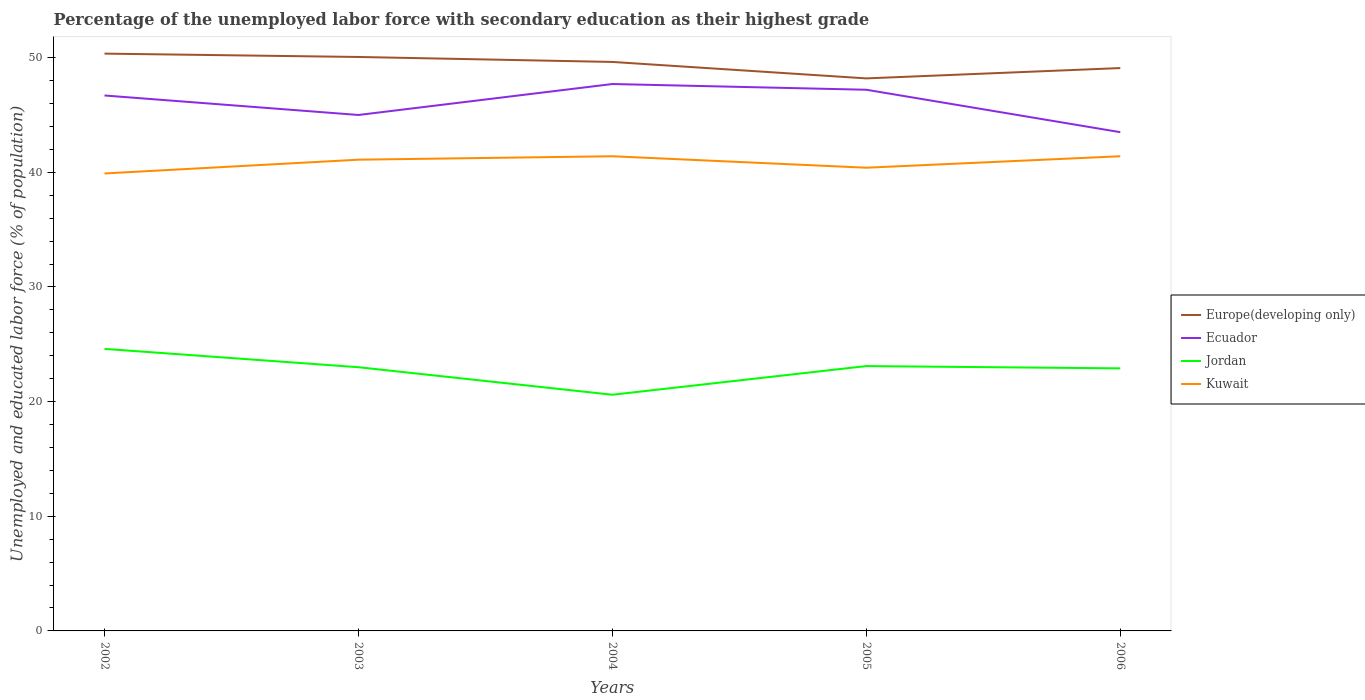How many different coloured lines are there?
Provide a succinct answer. 4. Is the number of lines equal to the number of legend labels?
Offer a very short reply. Yes. Across all years, what is the maximum percentage of the unemployed labor force with secondary education in Jordan?
Offer a terse response. 20.6. In which year was the percentage of the unemployed labor force with secondary education in Jordan maximum?
Your response must be concise. 2004. What is the total percentage of the unemployed labor force with secondary education in Jordan in the graph?
Offer a very short reply. -2.3. What is the difference between the highest and the second highest percentage of the unemployed labor force with secondary education in Europe(developing only)?
Provide a succinct answer. 2.16. Where does the legend appear in the graph?
Offer a terse response. Center right. What is the title of the graph?
Provide a short and direct response. Percentage of the unemployed labor force with secondary education as their highest grade. What is the label or title of the Y-axis?
Provide a short and direct response. Unemployed and educated labor force (% of population). What is the Unemployed and educated labor force (% of population) in Europe(developing only) in 2002?
Make the answer very short. 50.35. What is the Unemployed and educated labor force (% of population) of Ecuador in 2002?
Provide a succinct answer. 46.7. What is the Unemployed and educated labor force (% of population) of Jordan in 2002?
Your answer should be compact. 24.6. What is the Unemployed and educated labor force (% of population) in Kuwait in 2002?
Make the answer very short. 39.9. What is the Unemployed and educated labor force (% of population) of Europe(developing only) in 2003?
Keep it short and to the point. 50.06. What is the Unemployed and educated labor force (% of population) of Kuwait in 2003?
Keep it short and to the point. 41.1. What is the Unemployed and educated labor force (% of population) in Europe(developing only) in 2004?
Offer a very short reply. 49.63. What is the Unemployed and educated labor force (% of population) of Ecuador in 2004?
Your response must be concise. 47.7. What is the Unemployed and educated labor force (% of population) of Jordan in 2004?
Your answer should be very brief. 20.6. What is the Unemployed and educated labor force (% of population) of Kuwait in 2004?
Provide a short and direct response. 41.4. What is the Unemployed and educated labor force (% of population) in Europe(developing only) in 2005?
Provide a succinct answer. 48.19. What is the Unemployed and educated labor force (% of population) of Ecuador in 2005?
Give a very brief answer. 47.2. What is the Unemployed and educated labor force (% of population) of Jordan in 2005?
Provide a short and direct response. 23.1. What is the Unemployed and educated labor force (% of population) in Kuwait in 2005?
Make the answer very short. 40.4. What is the Unemployed and educated labor force (% of population) of Europe(developing only) in 2006?
Offer a terse response. 49.09. What is the Unemployed and educated labor force (% of population) of Ecuador in 2006?
Provide a short and direct response. 43.5. What is the Unemployed and educated labor force (% of population) of Jordan in 2006?
Provide a succinct answer. 22.9. What is the Unemployed and educated labor force (% of population) in Kuwait in 2006?
Offer a terse response. 41.4. Across all years, what is the maximum Unemployed and educated labor force (% of population) of Europe(developing only)?
Keep it short and to the point. 50.35. Across all years, what is the maximum Unemployed and educated labor force (% of population) of Ecuador?
Ensure brevity in your answer.  47.7. Across all years, what is the maximum Unemployed and educated labor force (% of population) in Jordan?
Offer a terse response. 24.6. Across all years, what is the maximum Unemployed and educated labor force (% of population) of Kuwait?
Your answer should be compact. 41.4. Across all years, what is the minimum Unemployed and educated labor force (% of population) of Europe(developing only)?
Give a very brief answer. 48.19. Across all years, what is the minimum Unemployed and educated labor force (% of population) in Ecuador?
Make the answer very short. 43.5. Across all years, what is the minimum Unemployed and educated labor force (% of population) in Jordan?
Offer a very short reply. 20.6. Across all years, what is the minimum Unemployed and educated labor force (% of population) in Kuwait?
Offer a very short reply. 39.9. What is the total Unemployed and educated labor force (% of population) in Europe(developing only) in the graph?
Provide a succinct answer. 247.32. What is the total Unemployed and educated labor force (% of population) in Ecuador in the graph?
Offer a very short reply. 230.1. What is the total Unemployed and educated labor force (% of population) in Jordan in the graph?
Your answer should be compact. 114.2. What is the total Unemployed and educated labor force (% of population) of Kuwait in the graph?
Offer a very short reply. 204.2. What is the difference between the Unemployed and educated labor force (% of population) in Europe(developing only) in 2002 and that in 2003?
Your answer should be compact. 0.29. What is the difference between the Unemployed and educated labor force (% of population) of Jordan in 2002 and that in 2003?
Your answer should be very brief. 1.6. What is the difference between the Unemployed and educated labor force (% of population) of Kuwait in 2002 and that in 2003?
Provide a succinct answer. -1.2. What is the difference between the Unemployed and educated labor force (% of population) in Europe(developing only) in 2002 and that in 2004?
Keep it short and to the point. 0.72. What is the difference between the Unemployed and educated labor force (% of population) of Ecuador in 2002 and that in 2004?
Offer a very short reply. -1. What is the difference between the Unemployed and educated labor force (% of population) of Europe(developing only) in 2002 and that in 2005?
Give a very brief answer. 2.16. What is the difference between the Unemployed and educated labor force (% of population) in Jordan in 2002 and that in 2005?
Provide a short and direct response. 1.5. What is the difference between the Unemployed and educated labor force (% of population) in Kuwait in 2002 and that in 2005?
Your response must be concise. -0.5. What is the difference between the Unemployed and educated labor force (% of population) in Europe(developing only) in 2002 and that in 2006?
Provide a short and direct response. 1.26. What is the difference between the Unemployed and educated labor force (% of population) of Ecuador in 2002 and that in 2006?
Ensure brevity in your answer.  3.2. What is the difference between the Unemployed and educated labor force (% of population) in Jordan in 2002 and that in 2006?
Make the answer very short. 1.7. What is the difference between the Unemployed and educated labor force (% of population) of Kuwait in 2002 and that in 2006?
Provide a succinct answer. -1.5. What is the difference between the Unemployed and educated labor force (% of population) in Europe(developing only) in 2003 and that in 2004?
Keep it short and to the point. 0.43. What is the difference between the Unemployed and educated labor force (% of population) of Jordan in 2003 and that in 2004?
Give a very brief answer. 2.4. What is the difference between the Unemployed and educated labor force (% of population) in Kuwait in 2003 and that in 2004?
Make the answer very short. -0.3. What is the difference between the Unemployed and educated labor force (% of population) of Europe(developing only) in 2003 and that in 2005?
Keep it short and to the point. 1.87. What is the difference between the Unemployed and educated labor force (% of population) in Ecuador in 2003 and that in 2005?
Offer a terse response. -2.2. What is the difference between the Unemployed and educated labor force (% of population) in Jordan in 2003 and that in 2005?
Give a very brief answer. -0.1. What is the difference between the Unemployed and educated labor force (% of population) in Kuwait in 2003 and that in 2005?
Your answer should be compact. 0.7. What is the difference between the Unemployed and educated labor force (% of population) in Europe(developing only) in 2003 and that in 2006?
Offer a terse response. 0.97. What is the difference between the Unemployed and educated labor force (% of population) of Ecuador in 2003 and that in 2006?
Your response must be concise. 1.5. What is the difference between the Unemployed and educated labor force (% of population) in Europe(developing only) in 2004 and that in 2005?
Your answer should be compact. 1.44. What is the difference between the Unemployed and educated labor force (% of population) in Kuwait in 2004 and that in 2005?
Your response must be concise. 1. What is the difference between the Unemployed and educated labor force (% of population) in Europe(developing only) in 2004 and that in 2006?
Offer a very short reply. 0.53. What is the difference between the Unemployed and educated labor force (% of population) of Ecuador in 2004 and that in 2006?
Offer a very short reply. 4.2. What is the difference between the Unemployed and educated labor force (% of population) of Europe(developing only) in 2005 and that in 2006?
Make the answer very short. -0.9. What is the difference between the Unemployed and educated labor force (% of population) in Ecuador in 2005 and that in 2006?
Your response must be concise. 3.7. What is the difference between the Unemployed and educated labor force (% of population) of Europe(developing only) in 2002 and the Unemployed and educated labor force (% of population) of Ecuador in 2003?
Provide a succinct answer. 5.35. What is the difference between the Unemployed and educated labor force (% of population) of Europe(developing only) in 2002 and the Unemployed and educated labor force (% of population) of Jordan in 2003?
Offer a very short reply. 27.35. What is the difference between the Unemployed and educated labor force (% of population) in Europe(developing only) in 2002 and the Unemployed and educated labor force (% of population) in Kuwait in 2003?
Offer a terse response. 9.25. What is the difference between the Unemployed and educated labor force (% of population) in Ecuador in 2002 and the Unemployed and educated labor force (% of population) in Jordan in 2003?
Keep it short and to the point. 23.7. What is the difference between the Unemployed and educated labor force (% of population) of Ecuador in 2002 and the Unemployed and educated labor force (% of population) of Kuwait in 2003?
Your response must be concise. 5.6. What is the difference between the Unemployed and educated labor force (% of population) in Jordan in 2002 and the Unemployed and educated labor force (% of population) in Kuwait in 2003?
Keep it short and to the point. -16.5. What is the difference between the Unemployed and educated labor force (% of population) of Europe(developing only) in 2002 and the Unemployed and educated labor force (% of population) of Ecuador in 2004?
Your response must be concise. 2.65. What is the difference between the Unemployed and educated labor force (% of population) of Europe(developing only) in 2002 and the Unemployed and educated labor force (% of population) of Jordan in 2004?
Offer a terse response. 29.75. What is the difference between the Unemployed and educated labor force (% of population) of Europe(developing only) in 2002 and the Unemployed and educated labor force (% of population) of Kuwait in 2004?
Your answer should be very brief. 8.95. What is the difference between the Unemployed and educated labor force (% of population) of Ecuador in 2002 and the Unemployed and educated labor force (% of population) of Jordan in 2004?
Offer a very short reply. 26.1. What is the difference between the Unemployed and educated labor force (% of population) in Ecuador in 2002 and the Unemployed and educated labor force (% of population) in Kuwait in 2004?
Offer a very short reply. 5.3. What is the difference between the Unemployed and educated labor force (% of population) in Jordan in 2002 and the Unemployed and educated labor force (% of population) in Kuwait in 2004?
Give a very brief answer. -16.8. What is the difference between the Unemployed and educated labor force (% of population) of Europe(developing only) in 2002 and the Unemployed and educated labor force (% of population) of Ecuador in 2005?
Ensure brevity in your answer.  3.15. What is the difference between the Unemployed and educated labor force (% of population) of Europe(developing only) in 2002 and the Unemployed and educated labor force (% of population) of Jordan in 2005?
Provide a short and direct response. 27.25. What is the difference between the Unemployed and educated labor force (% of population) in Europe(developing only) in 2002 and the Unemployed and educated labor force (% of population) in Kuwait in 2005?
Your response must be concise. 9.95. What is the difference between the Unemployed and educated labor force (% of population) of Ecuador in 2002 and the Unemployed and educated labor force (% of population) of Jordan in 2005?
Offer a very short reply. 23.6. What is the difference between the Unemployed and educated labor force (% of population) of Ecuador in 2002 and the Unemployed and educated labor force (% of population) of Kuwait in 2005?
Give a very brief answer. 6.3. What is the difference between the Unemployed and educated labor force (% of population) of Jordan in 2002 and the Unemployed and educated labor force (% of population) of Kuwait in 2005?
Keep it short and to the point. -15.8. What is the difference between the Unemployed and educated labor force (% of population) of Europe(developing only) in 2002 and the Unemployed and educated labor force (% of population) of Ecuador in 2006?
Your answer should be compact. 6.85. What is the difference between the Unemployed and educated labor force (% of population) of Europe(developing only) in 2002 and the Unemployed and educated labor force (% of population) of Jordan in 2006?
Provide a succinct answer. 27.45. What is the difference between the Unemployed and educated labor force (% of population) in Europe(developing only) in 2002 and the Unemployed and educated labor force (% of population) in Kuwait in 2006?
Your response must be concise. 8.95. What is the difference between the Unemployed and educated labor force (% of population) in Ecuador in 2002 and the Unemployed and educated labor force (% of population) in Jordan in 2006?
Keep it short and to the point. 23.8. What is the difference between the Unemployed and educated labor force (% of population) of Jordan in 2002 and the Unemployed and educated labor force (% of population) of Kuwait in 2006?
Offer a very short reply. -16.8. What is the difference between the Unemployed and educated labor force (% of population) in Europe(developing only) in 2003 and the Unemployed and educated labor force (% of population) in Ecuador in 2004?
Your answer should be compact. 2.36. What is the difference between the Unemployed and educated labor force (% of population) of Europe(developing only) in 2003 and the Unemployed and educated labor force (% of population) of Jordan in 2004?
Your answer should be very brief. 29.46. What is the difference between the Unemployed and educated labor force (% of population) in Europe(developing only) in 2003 and the Unemployed and educated labor force (% of population) in Kuwait in 2004?
Your answer should be very brief. 8.66. What is the difference between the Unemployed and educated labor force (% of population) in Ecuador in 2003 and the Unemployed and educated labor force (% of population) in Jordan in 2004?
Ensure brevity in your answer.  24.4. What is the difference between the Unemployed and educated labor force (% of population) in Ecuador in 2003 and the Unemployed and educated labor force (% of population) in Kuwait in 2004?
Give a very brief answer. 3.6. What is the difference between the Unemployed and educated labor force (% of population) of Jordan in 2003 and the Unemployed and educated labor force (% of population) of Kuwait in 2004?
Give a very brief answer. -18.4. What is the difference between the Unemployed and educated labor force (% of population) of Europe(developing only) in 2003 and the Unemployed and educated labor force (% of population) of Ecuador in 2005?
Offer a very short reply. 2.86. What is the difference between the Unemployed and educated labor force (% of population) in Europe(developing only) in 2003 and the Unemployed and educated labor force (% of population) in Jordan in 2005?
Your answer should be compact. 26.96. What is the difference between the Unemployed and educated labor force (% of population) in Europe(developing only) in 2003 and the Unemployed and educated labor force (% of population) in Kuwait in 2005?
Offer a very short reply. 9.66. What is the difference between the Unemployed and educated labor force (% of population) in Ecuador in 2003 and the Unemployed and educated labor force (% of population) in Jordan in 2005?
Your answer should be compact. 21.9. What is the difference between the Unemployed and educated labor force (% of population) of Ecuador in 2003 and the Unemployed and educated labor force (% of population) of Kuwait in 2005?
Offer a very short reply. 4.6. What is the difference between the Unemployed and educated labor force (% of population) of Jordan in 2003 and the Unemployed and educated labor force (% of population) of Kuwait in 2005?
Offer a very short reply. -17.4. What is the difference between the Unemployed and educated labor force (% of population) in Europe(developing only) in 2003 and the Unemployed and educated labor force (% of population) in Ecuador in 2006?
Your answer should be compact. 6.56. What is the difference between the Unemployed and educated labor force (% of population) of Europe(developing only) in 2003 and the Unemployed and educated labor force (% of population) of Jordan in 2006?
Your answer should be compact. 27.16. What is the difference between the Unemployed and educated labor force (% of population) in Europe(developing only) in 2003 and the Unemployed and educated labor force (% of population) in Kuwait in 2006?
Keep it short and to the point. 8.66. What is the difference between the Unemployed and educated labor force (% of population) in Ecuador in 2003 and the Unemployed and educated labor force (% of population) in Jordan in 2006?
Offer a very short reply. 22.1. What is the difference between the Unemployed and educated labor force (% of population) of Ecuador in 2003 and the Unemployed and educated labor force (% of population) of Kuwait in 2006?
Your answer should be compact. 3.6. What is the difference between the Unemployed and educated labor force (% of population) in Jordan in 2003 and the Unemployed and educated labor force (% of population) in Kuwait in 2006?
Offer a terse response. -18.4. What is the difference between the Unemployed and educated labor force (% of population) of Europe(developing only) in 2004 and the Unemployed and educated labor force (% of population) of Ecuador in 2005?
Keep it short and to the point. 2.43. What is the difference between the Unemployed and educated labor force (% of population) in Europe(developing only) in 2004 and the Unemployed and educated labor force (% of population) in Jordan in 2005?
Your response must be concise. 26.53. What is the difference between the Unemployed and educated labor force (% of population) in Europe(developing only) in 2004 and the Unemployed and educated labor force (% of population) in Kuwait in 2005?
Keep it short and to the point. 9.23. What is the difference between the Unemployed and educated labor force (% of population) in Ecuador in 2004 and the Unemployed and educated labor force (% of population) in Jordan in 2005?
Provide a short and direct response. 24.6. What is the difference between the Unemployed and educated labor force (% of population) in Ecuador in 2004 and the Unemployed and educated labor force (% of population) in Kuwait in 2005?
Ensure brevity in your answer.  7.3. What is the difference between the Unemployed and educated labor force (% of population) of Jordan in 2004 and the Unemployed and educated labor force (% of population) of Kuwait in 2005?
Your response must be concise. -19.8. What is the difference between the Unemployed and educated labor force (% of population) of Europe(developing only) in 2004 and the Unemployed and educated labor force (% of population) of Ecuador in 2006?
Provide a succinct answer. 6.13. What is the difference between the Unemployed and educated labor force (% of population) of Europe(developing only) in 2004 and the Unemployed and educated labor force (% of population) of Jordan in 2006?
Make the answer very short. 26.73. What is the difference between the Unemployed and educated labor force (% of population) in Europe(developing only) in 2004 and the Unemployed and educated labor force (% of population) in Kuwait in 2006?
Provide a short and direct response. 8.23. What is the difference between the Unemployed and educated labor force (% of population) in Ecuador in 2004 and the Unemployed and educated labor force (% of population) in Jordan in 2006?
Offer a terse response. 24.8. What is the difference between the Unemployed and educated labor force (% of population) in Jordan in 2004 and the Unemployed and educated labor force (% of population) in Kuwait in 2006?
Your answer should be compact. -20.8. What is the difference between the Unemployed and educated labor force (% of population) in Europe(developing only) in 2005 and the Unemployed and educated labor force (% of population) in Ecuador in 2006?
Your response must be concise. 4.69. What is the difference between the Unemployed and educated labor force (% of population) of Europe(developing only) in 2005 and the Unemployed and educated labor force (% of population) of Jordan in 2006?
Keep it short and to the point. 25.29. What is the difference between the Unemployed and educated labor force (% of population) of Europe(developing only) in 2005 and the Unemployed and educated labor force (% of population) of Kuwait in 2006?
Ensure brevity in your answer.  6.79. What is the difference between the Unemployed and educated labor force (% of population) in Ecuador in 2005 and the Unemployed and educated labor force (% of population) in Jordan in 2006?
Ensure brevity in your answer.  24.3. What is the difference between the Unemployed and educated labor force (% of population) in Ecuador in 2005 and the Unemployed and educated labor force (% of population) in Kuwait in 2006?
Give a very brief answer. 5.8. What is the difference between the Unemployed and educated labor force (% of population) of Jordan in 2005 and the Unemployed and educated labor force (% of population) of Kuwait in 2006?
Make the answer very short. -18.3. What is the average Unemployed and educated labor force (% of population) of Europe(developing only) per year?
Give a very brief answer. 49.46. What is the average Unemployed and educated labor force (% of population) in Ecuador per year?
Keep it short and to the point. 46.02. What is the average Unemployed and educated labor force (% of population) of Jordan per year?
Your response must be concise. 22.84. What is the average Unemployed and educated labor force (% of population) in Kuwait per year?
Offer a very short reply. 40.84. In the year 2002, what is the difference between the Unemployed and educated labor force (% of population) of Europe(developing only) and Unemployed and educated labor force (% of population) of Ecuador?
Ensure brevity in your answer.  3.65. In the year 2002, what is the difference between the Unemployed and educated labor force (% of population) in Europe(developing only) and Unemployed and educated labor force (% of population) in Jordan?
Your response must be concise. 25.75. In the year 2002, what is the difference between the Unemployed and educated labor force (% of population) in Europe(developing only) and Unemployed and educated labor force (% of population) in Kuwait?
Provide a succinct answer. 10.45. In the year 2002, what is the difference between the Unemployed and educated labor force (% of population) in Ecuador and Unemployed and educated labor force (% of population) in Jordan?
Keep it short and to the point. 22.1. In the year 2002, what is the difference between the Unemployed and educated labor force (% of population) in Ecuador and Unemployed and educated labor force (% of population) in Kuwait?
Offer a terse response. 6.8. In the year 2002, what is the difference between the Unemployed and educated labor force (% of population) of Jordan and Unemployed and educated labor force (% of population) of Kuwait?
Your response must be concise. -15.3. In the year 2003, what is the difference between the Unemployed and educated labor force (% of population) of Europe(developing only) and Unemployed and educated labor force (% of population) of Ecuador?
Provide a succinct answer. 5.06. In the year 2003, what is the difference between the Unemployed and educated labor force (% of population) of Europe(developing only) and Unemployed and educated labor force (% of population) of Jordan?
Your answer should be very brief. 27.06. In the year 2003, what is the difference between the Unemployed and educated labor force (% of population) of Europe(developing only) and Unemployed and educated labor force (% of population) of Kuwait?
Your response must be concise. 8.96. In the year 2003, what is the difference between the Unemployed and educated labor force (% of population) in Jordan and Unemployed and educated labor force (% of population) in Kuwait?
Your response must be concise. -18.1. In the year 2004, what is the difference between the Unemployed and educated labor force (% of population) of Europe(developing only) and Unemployed and educated labor force (% of population) of Ecuador?
Your answer should be very brief. 1.93. In the year 2004, what is the difference between the Unemployed and educated labor force (% of population) of Europe(developing only) and Unemployed and educated labor force (% of population) of Jordan?
Offer a very short reply. 29.03. In the year 2004, what is the difference between the Unemployed and educated labor force (% of population) of Europe(developing only) and Unemployed and educated labor force (% of population) of Kuwait?
Your response must be concise. 8.23. In the year 2004, what is the difference between the Unemployed and educated labor force (% of population) of Ecuador and Unemployed and educated labor force (% of population) of Jordan?
Your answer should be very brief. 27.1. In the year 2004, what is the difference between the Unemployed and educated labor force (% of population) in Ecuador and Unemployed and educated labor force (% of population) in Kuwait?
Your response must be concise. 6.3. In the year 2004, what is the difference between the Unemployed and educated labor force (% of population) in Jordan and Unemployed and educated labor force (% of population) in Kuwait?
Offer a very short reply. -20.8. In the year 2005, what is the difference between the Unemployed and educated labor force (% of population) in Europe(developing only) and Unemployed and educated labor force (% of population) in Jordan?
Your answer should be very brief. 25.09. In the year 2005, what is the difference between the Unemployed and educated labor force (% of population) in Europe(developing only) and Unemployed and educated labor force (% of population) in Kuwait?
Keep it short and to the point. 7.79. In the year 2005, what is the difference between the Unemployed and educated labor force (% of population) in Ecuador and Unemployed and educated labor force (% of population) in Jordan?
Give a very brief answer. 24.1. In the year 2005, what is the difference between the Unemployed and educated labor force (% of population) in Jordan and Unemployed and educated labor force (% of population) in Kuwait?
Keep it short and to the point. -17.3. In the year 2006, what is the difference between the Unemployed and educated labor force (% of population) in Europe(developing only) and Unemployed and educated labor force (% of population) in Ecuador?
Ensure brevity in your answer.  5.59. In the year 2006, what is the difference between the Unemployed and educated labor force (% of population) of Europe(developing only) and Unemployed and educated labor force (% of population) of Jordan?
Make the answer very short. 26.19. In the year 2006, what is the difference between the Unemployed and educated labor force (% of population) of Europe(developing only) and Unemployed and educated labor force (% of population) of Kuwait?
Your answer should be very brief. 7.69. In the year 2006, what is the difference between the Unemployed and educated labor force (% of population) in Ecuador and Unemployed and educated labor force (% of population) in Jordan?
Provide a short and direct response. 20.6. In the year 2006, what is the difference between the Unemployed and educated labor force (% of population) in Jordan and Unemployed and educated labor force (% of population) in Kuwait?
Provide a short and direct response. -18.5. What is the ratio of the Unemployed and educated labor force (% of population) of Europe(developing only) in 2002 to that in 2003?
Give a very brief answer. 1.01. What is the ratio of the Unemployed and educated labor force (% of population) of Ecuador in 2002 to that in 2003?
Ensure brevity in your answer.  1.04. What is the ratio of the Unemployed and educated labor force (% of population) of Jordan in 2002 to that in 2003?
Provide a short and direct response. 1.07. What is the ratio of the Unemployed and educated labor force (% of population) of Kuwait in 2002 to that in 2003?
Provide a succinct answer. 0.97. What is the ratio of the Unemployed and educated labor force (% of population) in Europe(developing only) in 2002 to that in 2004?
Give a very brief answer. 1.01. What is the ratio of the Unemployed and educated labor force (% of population) in Jordan in 2002 to that in 2004?
Offer a very short reply. 1.19. What is the ratio of the Unemployed and educated labor force (% of population) in Kuwait in 2002 to that in 2004?
Give a very brief answer. 0.96. What is the ratio of the Unemployed and educated labor force (% of population) in Europe(developing only) in 2002 to that in 2005?
Your answer should be compact. 1.04. What is the ratio of the Unemployed and educated labor force (% of population) in Ecuador in 2002 to that in 2005?
Your answer should be very brief. 0.99. What is the ratio of the Unemployed and educated labor force (% of population) of Jordan in 2002 to that in 2005?
Provide a short and direct response. 1.06. What is the ratio of the Unemployed and educated labor force (% of population) in Kuwait in 2002 to that in 2005?
Your answer should be very brief. 0.99. What is the ratio of the Unemployed and educated labor force (% of population) in Europe(developing only) in 2002 to that in 2006?
Your response must be concise. 1.03. What is the ratio of the Unemployed and educated labor force (% of population) in Ecuador in 2002 to that in 2006?
Your answer should be very brief. 1.07. What is the ratio of the Unemployed and educated labor force (% of population) of Jordan in 2002 to that in 2006?
Make the answer very short. 1.07. What is the ratio of the Unemployed and educated labor force (% of population) in Kuwait in 2002 to that in 2006?
Provide a succinct answer. 0.96. What is the ratio of the Unemployed and educated labor force (% of population) of Europe(developing only) in 2003 to that in 2004?
Keep it short and to the point. 1.01. What is the ratio of the Unemployed and educated labor force (% of population) of Ecuador in 2003 to that in 2004?
Provide a short and direct response. 0.94. What is the ratio of the Unemployed and educated labor force (% of population) in Jordan in 2003 to that in 2004?
Your answer should be compact. 1.12. What is the ratio of the Unemployed and educated labor force (% of population) of Kuwait in 2003 to that in 2004?
Provide a short and direct response. 0.99. What is the ratio of the Unemployed and educated labor force (% of population) in Europe(developing only) in 2003 to that in 2005?
Your response must be concise. 1.04. What is the ratio of the Unemployed and educated labor force (% of population) in Ecuador in 2003 to that in 2005?
Your response must be concise. 0.95. What is the ratio of the Unemployed and educated labor force (% of population) of Kuwait in 2003 to that in 2005?
Provide a short and direct response. 1.02. What is the ratio of the Unemployed and educated labor force (% of population) in Europe(developing only) in 2003 to that in 2006?
Give a very brief answer. 1.02. What is the ratio of the Unemployed and educated labor force (% of population) of Ecuador in 2003 to that in 2006?
Give a very brief answer. 1.03. What is the ratio of the Unemployed and educated labor force (% of population) in Jordan in 2003 to that in 2006?
Give a very brief answer. 1. What is the ratio of the Unemployed and educated labor force (% of population) in Europe(developing only) in 2004 to that in 2005?
Make the answer very short. 1.03. What is the ratio of the Unemployed and educated labor force (% of population) in Ecuador in 2004 to that in 2005?
Give a very brief answer. 1.01. What is the ratio of the Unemployed and educated labor force (% of population) in Jordan in 2004 to that in 2005?
Give a very brief answer. 0.89. What is the ratio of the Unemployed and educated labor force (% of population) of Kuwait in 2004 to that in 2005?
Offer a very short reply. 1.02. What is the ratio of the Unemployed and educated labor force (% of population) of Europe(developing only) in 2004 to that in 2006?
Offer a very short reply. 1.01. What is the ratio of the Unemployed and educated labor force (% of population) of Ecuador in 2004 to that in 2006?
Your response must be concise. 1.1. What is the ratio of the Unemployed and educated labor force (% of population) of Jordan in 2004 to that in 2006?
Offer a terse response. 0.9. What is the ratio of the Unemployed and educated labor force (% of population) in Kuwait in 2004 to that in 2006?
Keep it short and to the point. 1. What is the ratio of the Unemployed and educated labor force (% of population) of Europe(developing only) in 2005 to that in 2006?
Give a very brief answer. 0.98. What is the ratio of the Unemployed and educated labor force (% of population) of Ecuador in 2005 to that in 2006?
Make the answer very short. 1.09. What is the ratio of the Unemployed and educated labor force (% of population) of Jordan in 2005 to that in 2006?
Offer a very short reply. 1.01. What is the ratio of the Unemployed and educated labor force (% of population) of Kuwait in 2005 to that in 2006?
Keep it short and to the point. 0.98. What is the difference between the highest and the second highest Unemployed and educated labor force (% of population) of Europe(developing only)?
Keep it short and to the point. 0.29. What is the difference between the highest and the second highest Unemployed and educated labor force (% of population) in Jordan?
Make the answer very short. 1.5. What is the difference between the highest and the lowest Unemployed and educated labor force (% of population) of Europe(developing only)?
Offer a terse response. 2.16. What is the difference between the highest and the lowest Unemployed and educated labor force (% of population) in Jordan?
Keep it short and to the point. 4. What is the difference between the highest and the lowest Unemployed and educated labor force (% of population) of Kuwait?
Your answer should be compact. 1.5. 